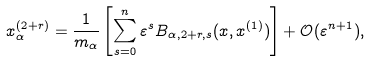<formula> <loc_0><loc_0><loc_500><loc_500>x _ { \alpha } ^ { ( 2 + r ) } & = \frac { 1 } { m _ { \alpha } } \left [ \sum _ { s = 0 } ^ { n } \varepsilon ^ { s } B _ { \alpha , 2 + r , s } ( x , x ^ { ( 1 ) } ) \right ] + \mathcal { O } ( \varepsilon ^ { n + 1 } ) ,</formula> 